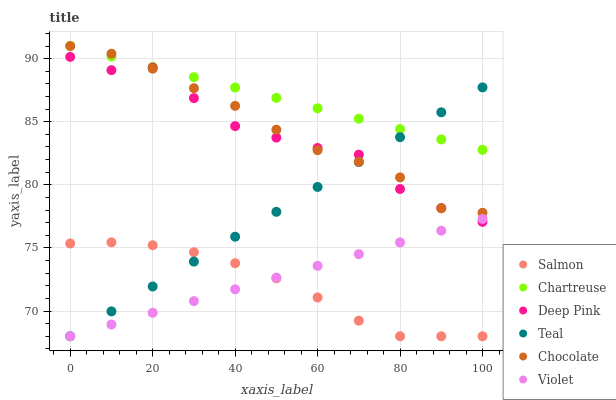Does Salmon have the minimum area under the curve?
Answer yes or no. Yes. Does Chartreuse have the maximum area under the curve?
Answer yes or no. Yes. Does Chocolate have the minimum area under the curve?
Answer yes or no. No. Does Chocolate have the maximum area under the curve?
Answer yes or no. No. Is Chartreuse the smoothest?
Answer yes or no. Yes. Is Deep Pink the roughest?
Answer yes or no. Yes. Is Salmon the smoothest?
Answer yes or no. No. Is Salmon the roughest?
Answer yes or no. No. Does Salmon have the lowest value?
Answer yes or no. Yes. Does Chocolate have the lowest value?
Answer yes or no. No. Does Chartreuse have the highest value?
Answer yes or no. Yes. Does Salmon have the highest value?
Answer yes or no. No. Is Violet less than Chartreuse?
Answer yes or no. Yes. Is Chartreuse greater than Violet?
Answer yes or no. Yes. Does Deep Pink intersect Chocolate?
Answer yes or no. Yes. Is Deep Pink less than Chocolate?
Answer yes or no. No. Is Deep Pink greater than Chocolate?
Answer yes or no. No. Does Violet intersect Chartreuse?
Answer yes or no. No. 